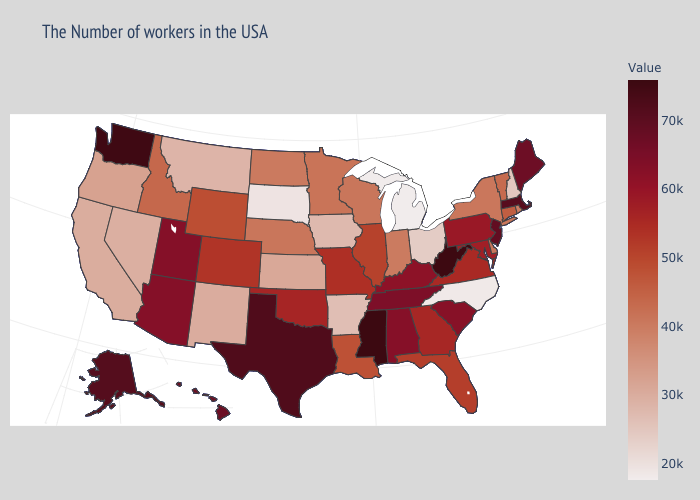Among the states that border South Carolina , does Georgia have the highest value?
Quick response, please. Yes. Among the states that border Illinois , does Missouri have the lowest value?
Answer briefly. No. Does Mississippi have the highest value in the USA?
Quick response, please. Yes. Which states have the lowest value in the USA?
Keep it brief. Michigan. Does Connecticut have the lowest value in the Northeast?
Write a very short answer. No. Does the map have missing data?
Keep it brief. No. Does Rhode Island have the highest value in the Northeast?
Give a very brief answer. No. Which states have the lowest value in the Northeast?
Answer briefly. New Hampshire. 